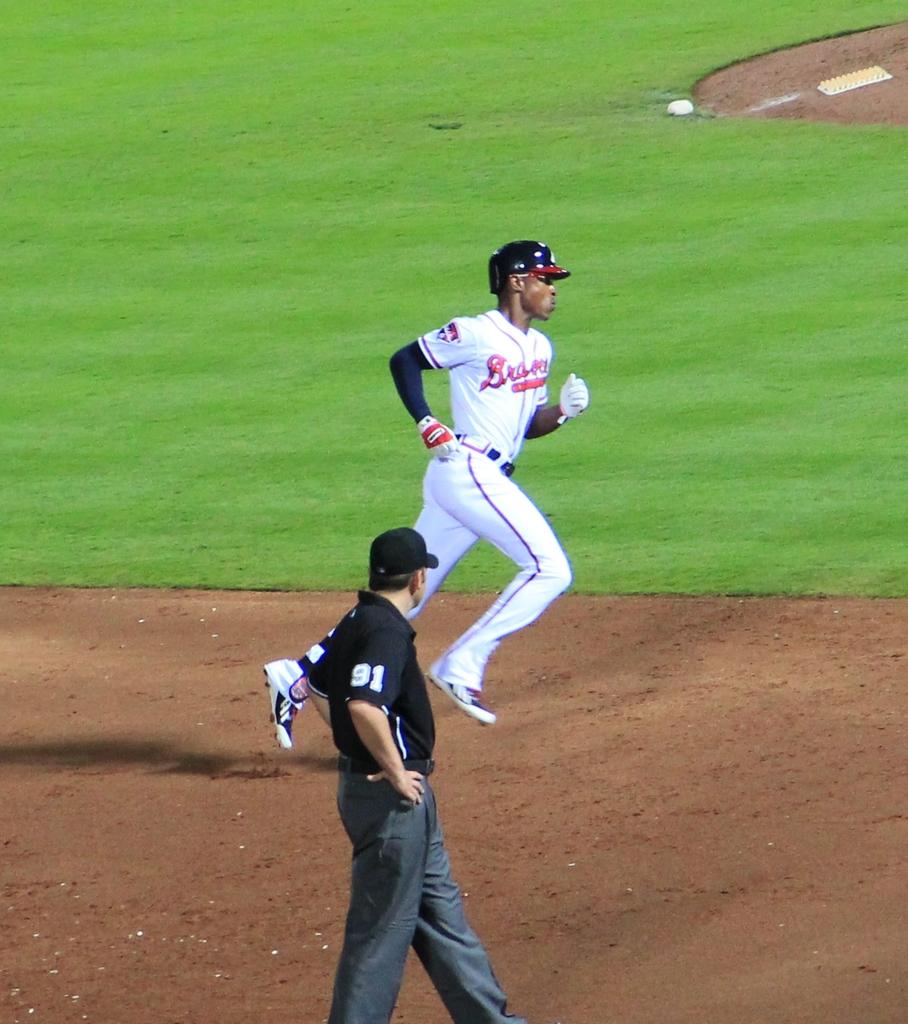What team is this?
Provide a succinct answer. Braves. 